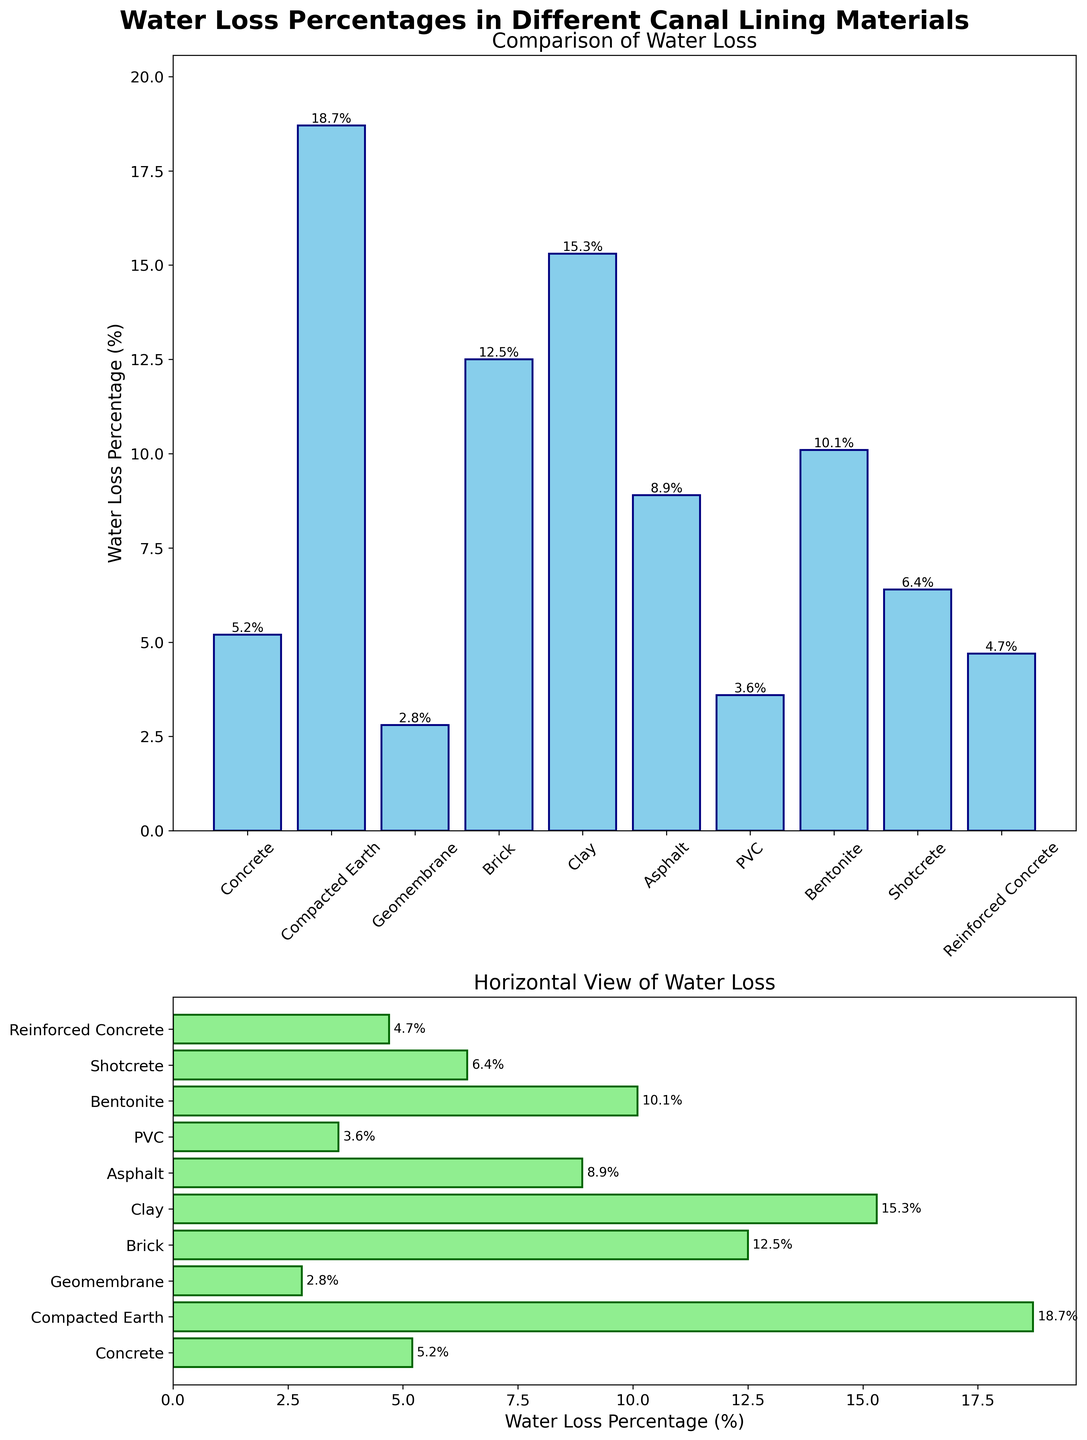What is the title of the overall figure? The title is usually at the top of the figure and summarizes what the figure is about. In this case, it reads "Water Loss Percentages in Different Canal Lining Materials".
Answer: Water Loss Percentages in Different Canal Lining Materials Which canal lining material has the lowest water loss percentage? By examining the bar heights in either the vertical or horizontal bar plot, the shortest bar represents the lowest value. The geomembrane has the lowest water loss percentage of 2.8%.
Answer: Geomembrane How many canal lining materials are being compared? Each bar in the plots represents a different canal lining material. By counting the bars, there are 10 materials being compared.
Answer: 10 What is the water loss percentage of the material with the highest loss? Identify the tallest bar in either the vertical or horizontal bar plot. The tallest bar corresponds to compacted earth with a water loss percentage of 18.7%.
Answer: 18.7% What is the difference in water loss percentage between the asphalt and bentonite? Find the bar heights for asphalt (8.9%) and bentonite (10.1%), then calculate the difference: 10.1% - 8.9% = 1.2%.
Answer: 1.2% Which canal lining materials have a water loss percentage less than 5%? Identify all bars with heights less than 5% in either plot. These materials are concrete (5.2% isn't less), geomembrane (2.8%), PVC (3.6%), and reinforced concrete (4.7%).
Answer: Geomembrane, PVC, Reinforced Concrete What is the average water loss percentage across all canal lining materials? Sum all the water loss percentages (5.2 + 18.7 + 2.8 + 12.5 + 15.3 + 8.9 + 3.6 + 10.1 + 6.4 + 4.7 = 88.2) and divide by the number of materials (10). The average is 88.2/10 = 8.82%.
Answer: 8.82% Which materials have a water loss percentage higher than 10%? Identify bars with heights greater than 10%. These materials are compacted earth (18.7%), brick (12.5%), and clay (15.3%).
Answer: Compacted Earth, Brick, Clay Which material has a lower water loss percentage, shotcrete or brick, and by how much? Compare the bar heights for shotcrete (6.4%) and brick (12.5%). The difference is 12.5% - 6.4% = 6.1%.
Answer: Shotcrete, 6.1% What is the median water loss percentage of the canal lining materials? List the percentages in ascending order: 2.8, 3.6, 4.7, 5.2, 6.4, 8.9, 10.1, 12.5, 15.3, 18.7. The median is the average of the 5th and 6th values: (6.4 + 8.9) / 2 = 7.65%.
Answer: 7.65% 